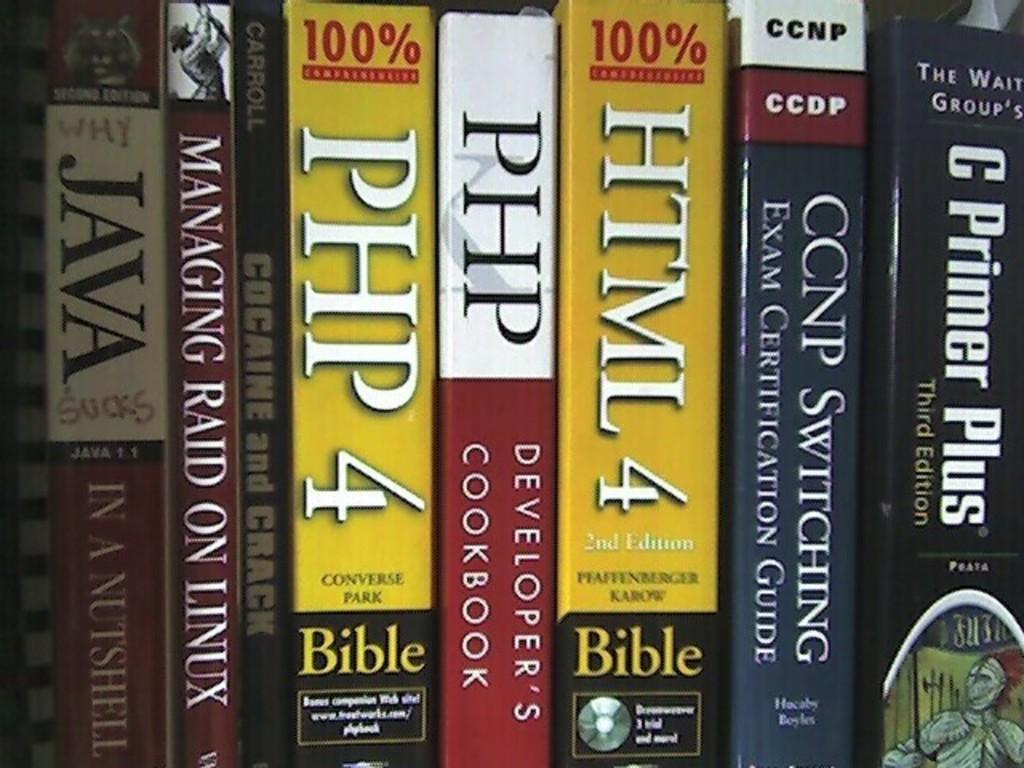Whats the title of first book on the left?
Make the answer very short. Java in a nutshell. The title of book is java?
Keep it short and to the point. Yes. 